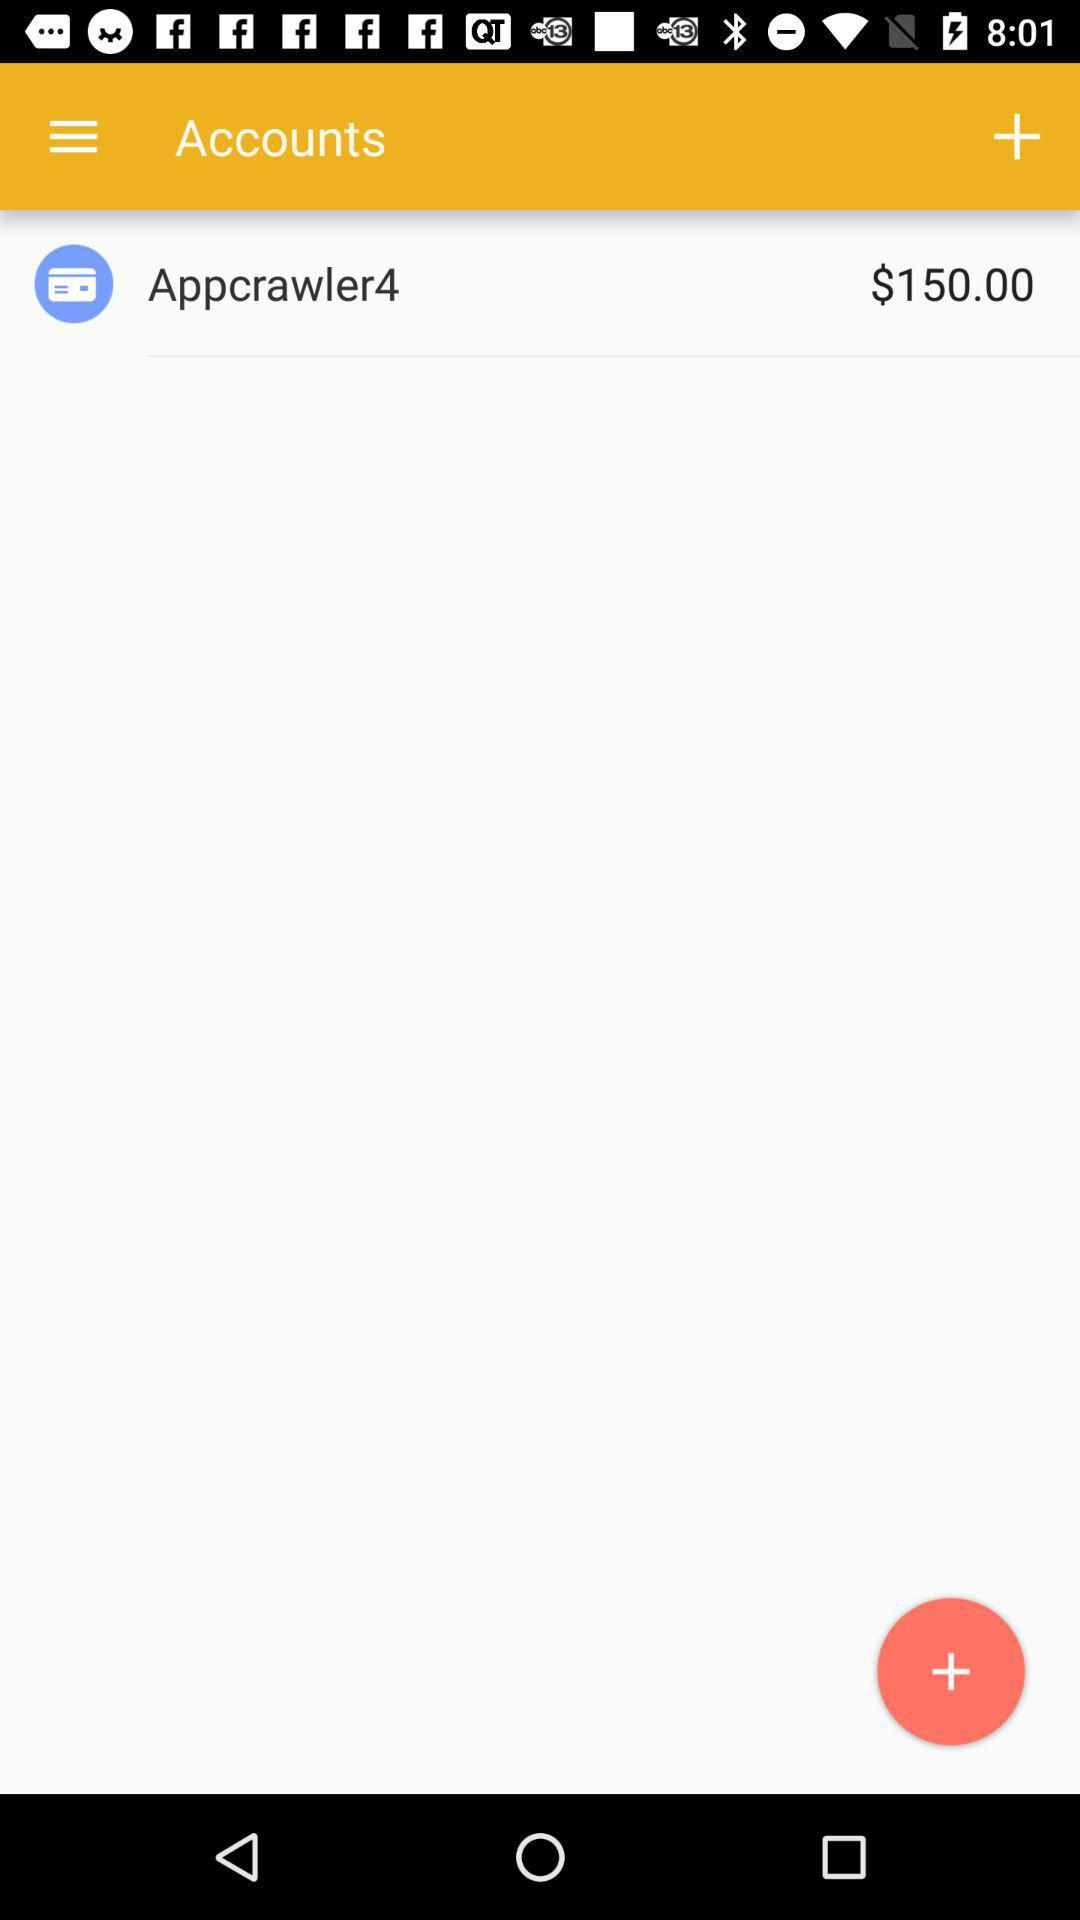What is the Appcrawler4's account balance?
Answer the question using a single word or phrase. It is $150. 